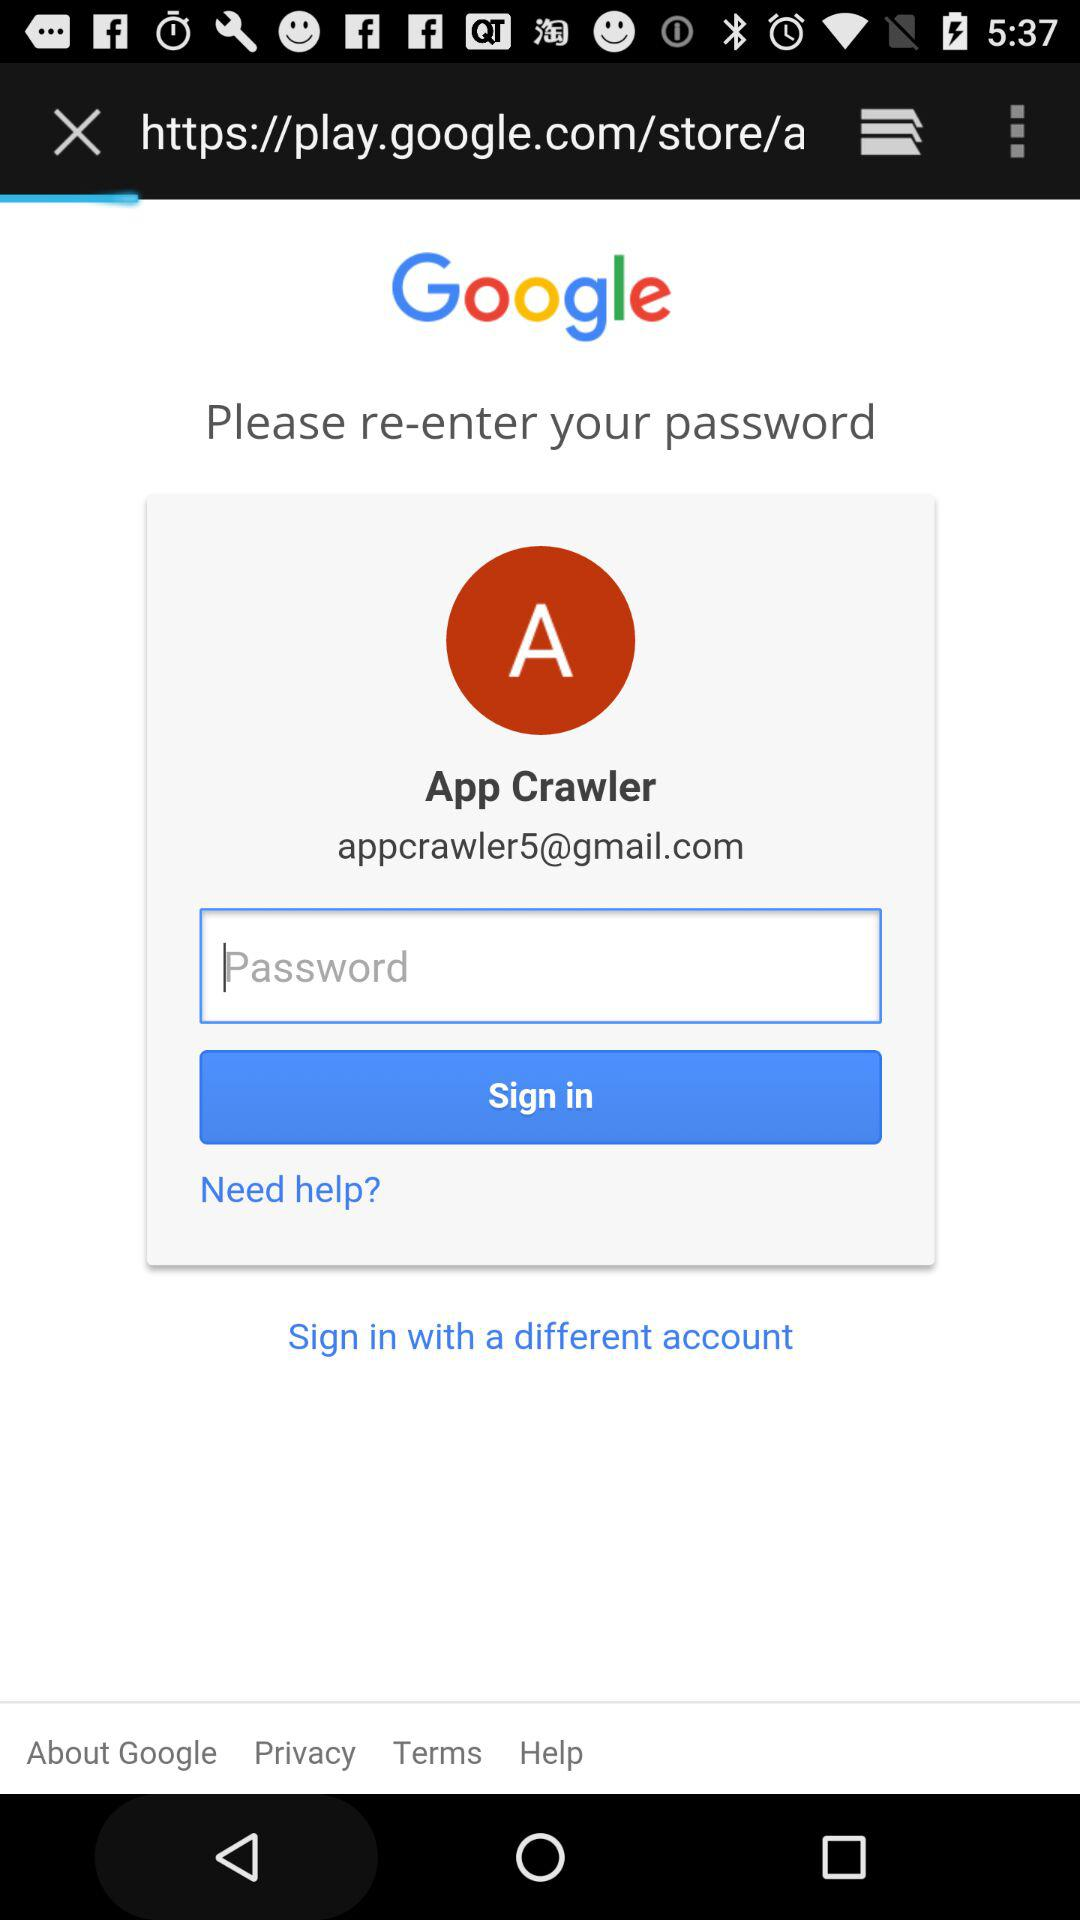What is the profile name? The profile name is App Crawler. 